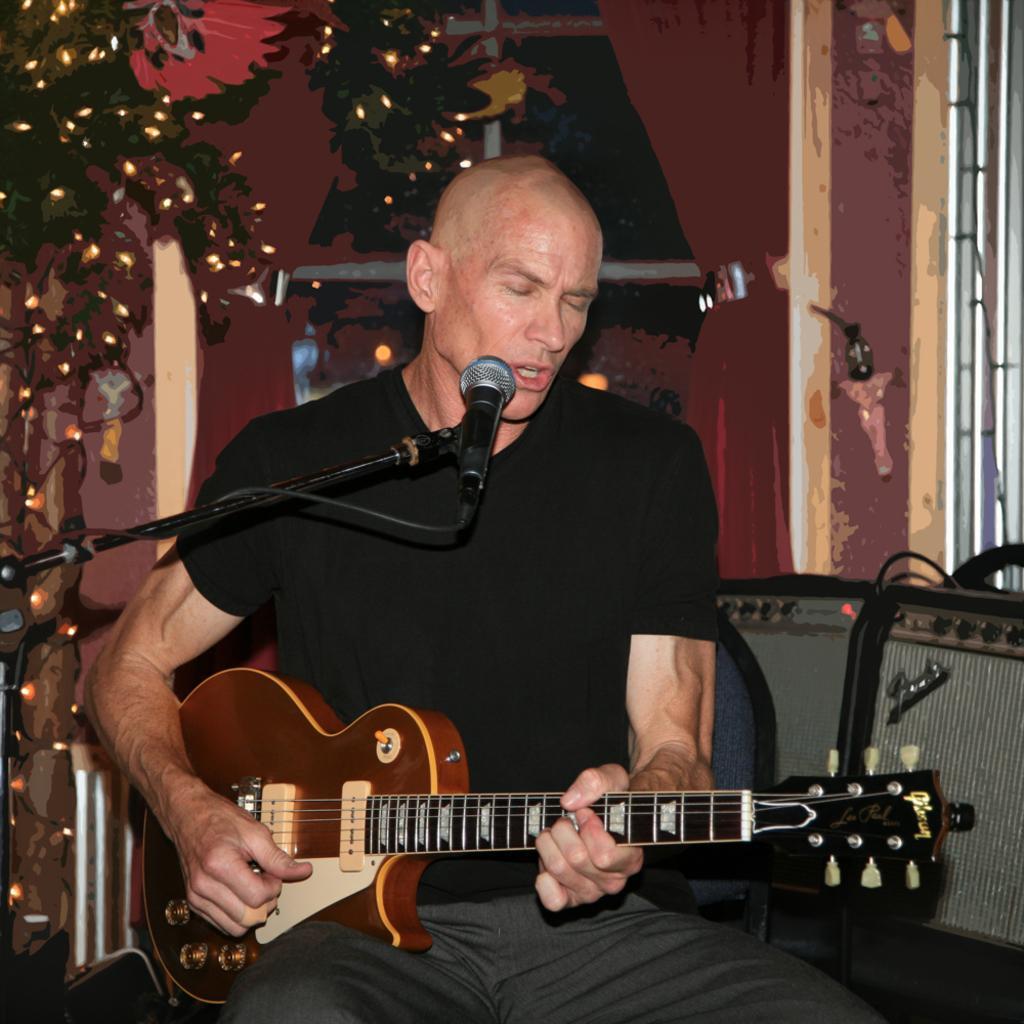In one or two sentences, can you explain what this image depicts? As we can see in the image there is a man sitting and holding guitar in his hand and singing on mic and there is a Christmas tree. 